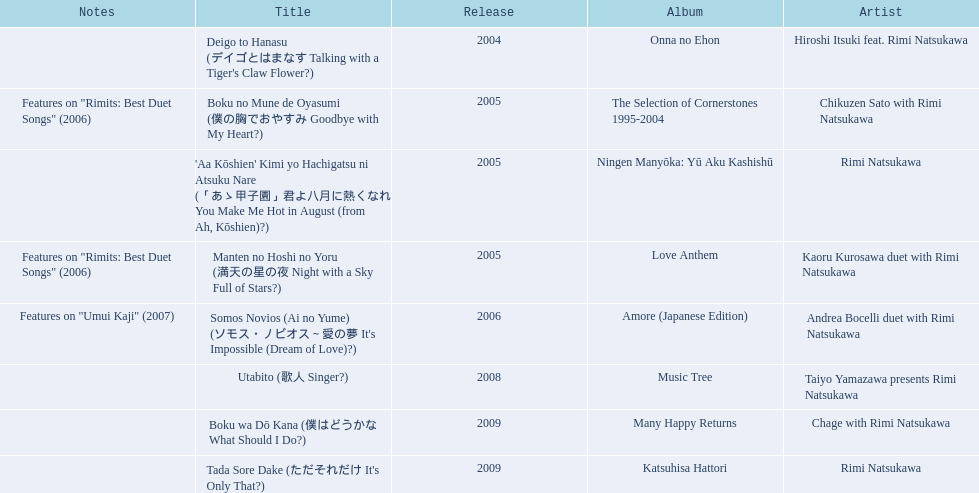What is the last title released? 2009. 